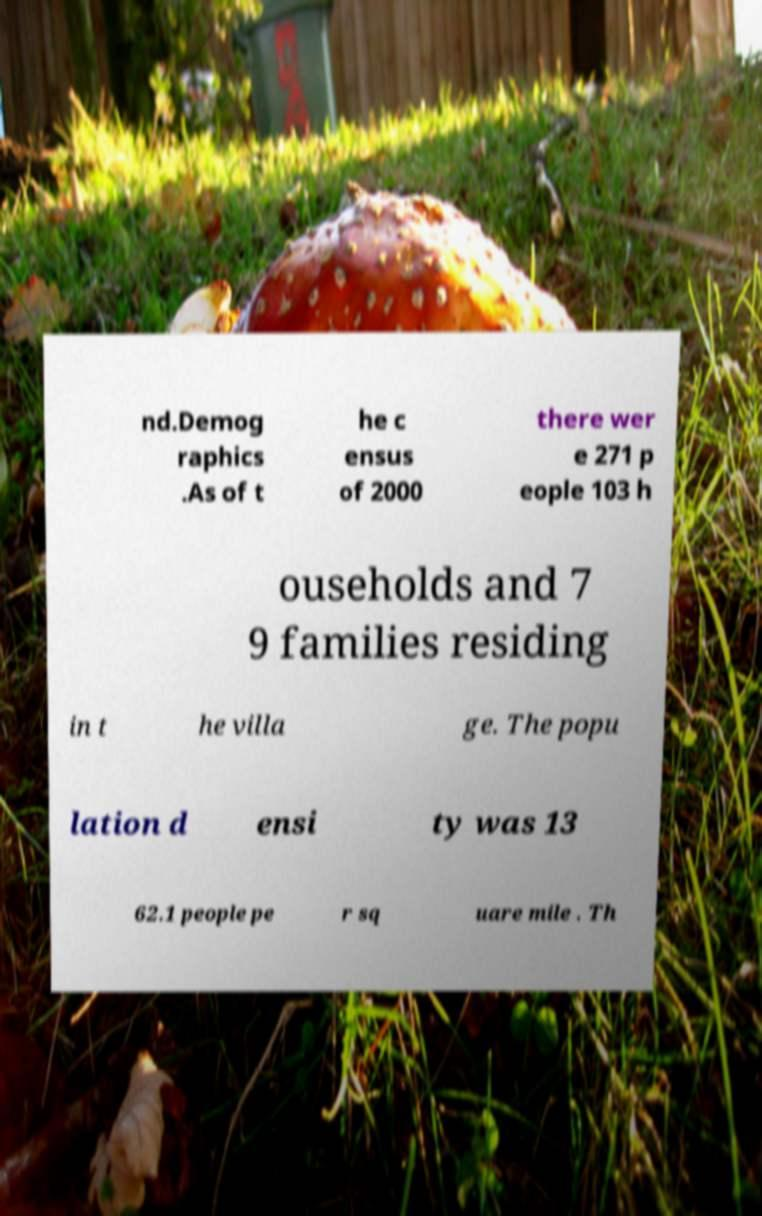Please identify and transcribe the text found in this image. nd.Demog raphics .As of t he c ensus of 2000 there wer e 271 p eople 103 h ouseholds and 7 9 families residing in t he villa ge. The popu lation d ensi ty was 13 62.1 people pe r sq uare mile . Th 